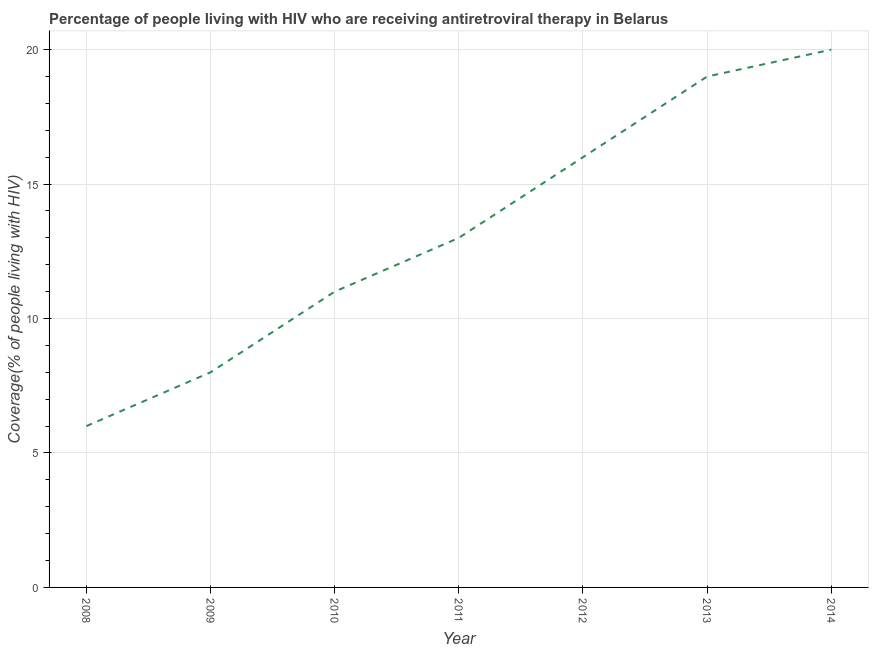What is the antiretroviral therapy coverage in 2009?
Ensure brevity in your answer.  8. Across all years, what is the maximum antiretroviral therapy coverage?
Provide a succinct answer. 20. In which year was the antiretroviral therapy coverage maximum?
Keep it short and to the point. 2014. In which year was the antiretroviral therapy coverage minimum?
Your answer should be very brief. 2008. What is the sum of the antiretroviral therapy coverage?
Your answer should be compact. 93. What is the difference between the antiretroviral therapy coverage in 2010 and 2012?
Ensure brevity in your answer.  -5. What is the average antiretroviral therapy coverage per year?
Offer a terse response. 13.29. What is the median antiretroviral therapy coverage?
Your answer should be very brief. 13. In how many years, is the antiretroviral therapy coverage greater than 10 %?
Provide a short and direct response. 5. Do a majority of the years between 2010 and 2009 (inclusive) have antiretroviral therapy coverage greater than 15 %?
Provide a succinct answer. No. What is the ratio of the antiretroviral therapy coverage in 2008 to that in 2010?
Provide a short and direct response. 0.55. Is the antiretroviral therapy coverage in 2010 less than that in 2014?
Offer a terse response. Yes. What is the difference between the highest and the second highest antiretroviral therapy coverage?
Give a very brief answer. 1. What is the difference between the highest and the lowest antiretroviral therapy coverage?
Your answer should be very brief. 14. How many lines are there?
Keep it short and to the point. 1. How many years are there in the graph?
Your answer should be compact. 7. Does the graph contain any zero values?
Make the answer very short. No. What is the title of the graph?
Your response must be concise. Percentage of people living with HIV who are receiving antiretroviral therapy in Belarus. What is the label or title of the X-axis?
Your response must be concise. Year. What is the label or title of the Y-axis?
Make the answer very short. Coverage(% of people living with HIV). What is the difference between the Coverage(% of people living with HIV) in 2008 and 2009?
Offer a terse response. -2. What is the difference between the Coverage(% of people living with HIV) in 2008 and 2011?
Ensure brevity in your answer.  -7. What is the difference between the Coverage(% of people living with HIV) in 2008 and 2014?
Keep it short and to the point. -14. What is the difference between the Coverage(% of people living with HIV) in 2009 and 2014?
Keep it short and to the point. -12. What is the difference between the Coverage(% of people living with HIV) in 2010 and 2011?
Offer a terse response. -2. What is the difference between the Coverage(% of people living with HIV) in 2010 and 2012?
Provide a short and direct response. -5. What is the difference between the Coverage(% of people living with HIV) in 2010 and 2013?
Your answer should be very brief. -8. What is the difference between the Coverage(% of people living with HIV) in 2010 and 2014?
Offer a terse response. -9. What is the difference between the Coverage(% of people living with HIV) in 2011 and 2012?
Give a very brief answer. -3. What is the difference between the Coverage(% of people living with HIV) in 2012 and 2014?
Your response must be concise. -4. What is the difference between the Coverage(% of people living with HIV) in 2013 and 2014?
Your answer should be very brief. -1. What is the ratio of the Coverage(% of people living with HIV) in 2008 to that in 2010?
Offer a very short reply. 0.55. What is the ratio of the Coverage(% of people living with HIV) in 2008 to that in 2011?
Keep it short and to the point. 0.46. What is the ratio of the Coverage(% of people living with HIV) in 2008 to that in 2012?
Ensure brevity in your answer.  0.38. What is the ratio of the Coverage(% of people living with HIV) in 2008 to that in 2013?
Make the answer very short. 0.32. What is the ratio of the Coverage(% of people living with HIV) in 2008 to that in 2014?
Give a very brief answer. 0.3. What is the ratio of the Coverage(% of people living with HIV) in 2009 to that in 2010?
Offer a very short reply. 0.73. What is the ratio of the Coverage(% of people living with HIV) in 2009 to that in 2011?
Your answer should be very brief. 0.61. What is the ratio of the Coverage(% of people living with HIV) in 2009 to that in 2013?
Your response must be concise. 0.42. What is the ratio of the Coverage(% of people living with HIV) in 2009 to that in 2014?
Give a very brief answer. 0.4. What is the ratio of the Coverage(% of people living with HIV) in 2010 to that in 2011?
Provide a short and direct response. 0.85. What is the ratio of the Coverage(% of people living with HIV) in 2010 to that in 2012?
Give a very brief answer. 0.69. What is the ratio of the Coverage(% of people living with HIV) in 2010 to that in 2013?
Offer a very short reply. 0.58. What is the ratio of the Coverage(% of people living with HIV) in 2010 to that in 2014?
Provide a short and direct response. 0.55. What is the ratio of the Coverage(% of people living with HIV) in 2011 to that in 2012?
Keep it short and to the point. 0.81. What is the ratio of the Coverage(% of people living with HIV) in 2011 to that in 2013?
Provide a short and direct response. 0.68. What is the ratio of the Coverage(% of people living with HIV) in 2011 to that in 2014?
Provide a succinct answer. 0.65. What is the ratio of the Coverage(% of people living with HIV) in 2012 to that in 2013?
Your answer should be very brief. 0.84. 